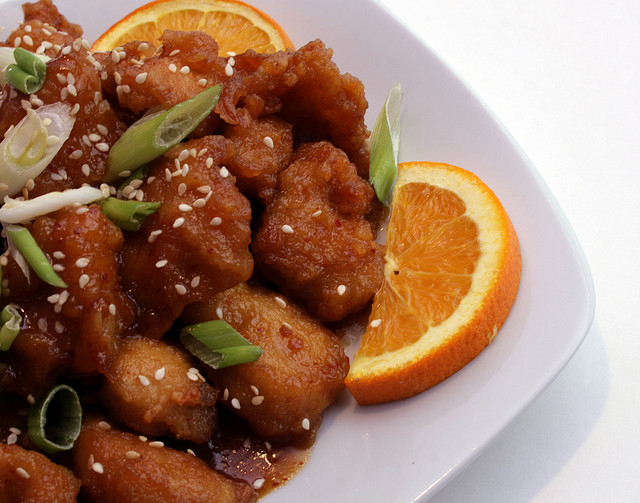<image>What kind of seafood is on top of the orange? It is ambiguous what kind of seafood is on top of the orange. It can be a shrimp, squid, or even a chicken. What kind of seafood is on top of the orange? It is not clear what kind of seafood is on top of the orange. There can be different options such as squid, shrimp, or sushi. 